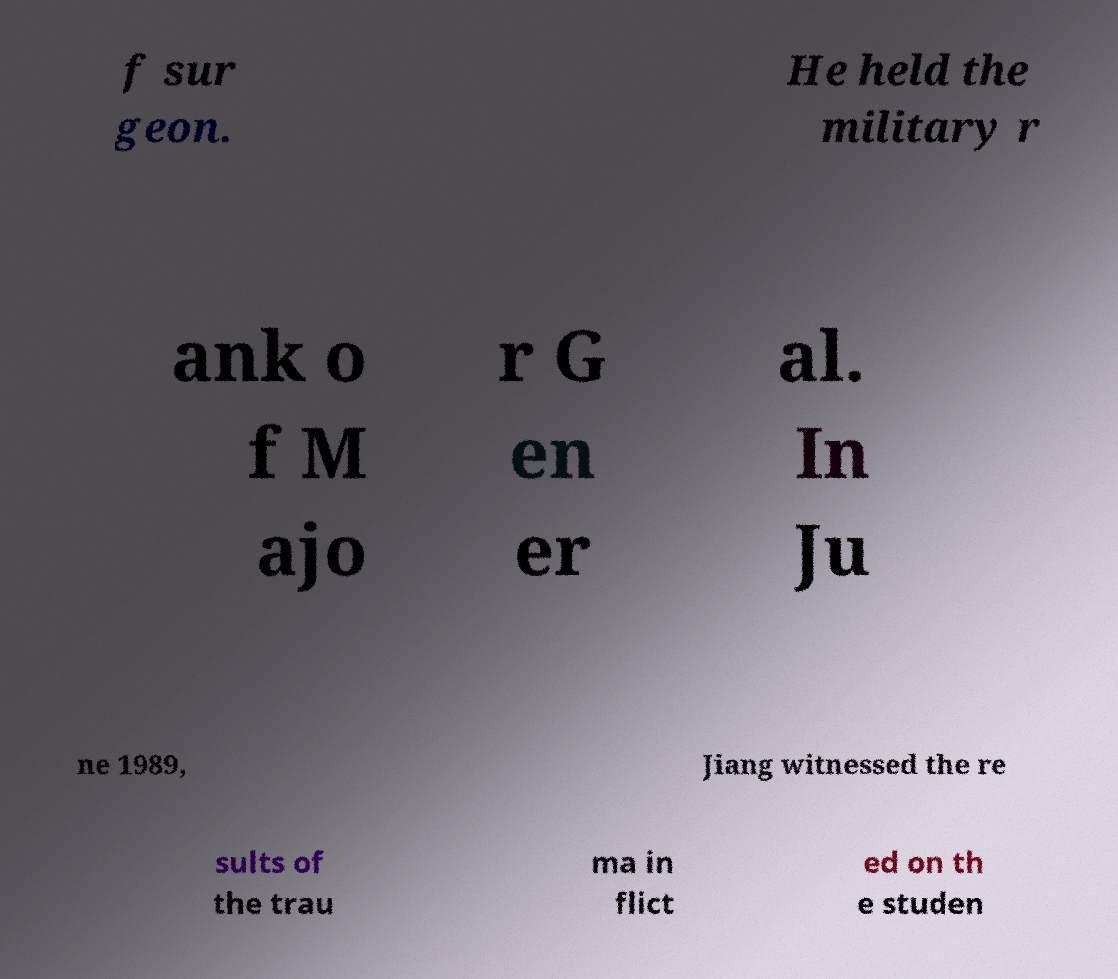What messages or text are displayed in this image? I need them in a readable, typed format. f sur geon. He held the military r ank o f M ajo r G en er al. In Ju ne 1989, Jiang witnessed the re sults of the trau ma in flict ed on th e studen 